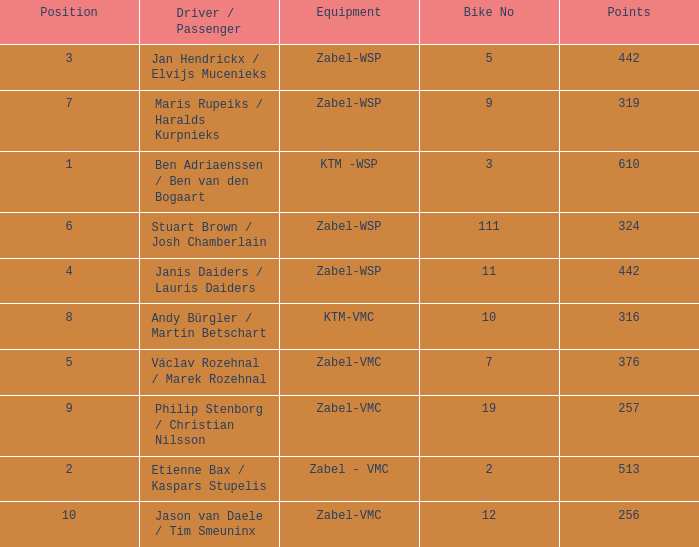What is the most elevated Position that has a Points of 257, and a Bike No littler than 19? None. 